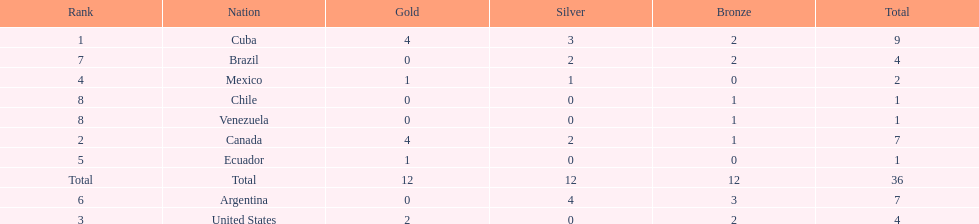Which nations won gold medals? Cuba, Canada, United States, Mexico, Ecuador. How many medals did each nation win? Cuba, 9, Canada, 7, United States, 4, Mexico, 2, Ecuador, 1. Which nation only won a gold medal? Ecuador. 